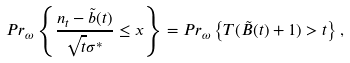<formula> <loc_0><loc_0><loc_500><loc_500>P r _ { \omega } \left \{ \frac { n _ { t } - \tilde { b } ( t ) } { \sqrt { t } \sigma ^ { * } } \leq x \right \} = P r _ { \omega } \left \{ T ( \tilde { B } ( t ) + 1 ) > t \right \} ,</formula> 